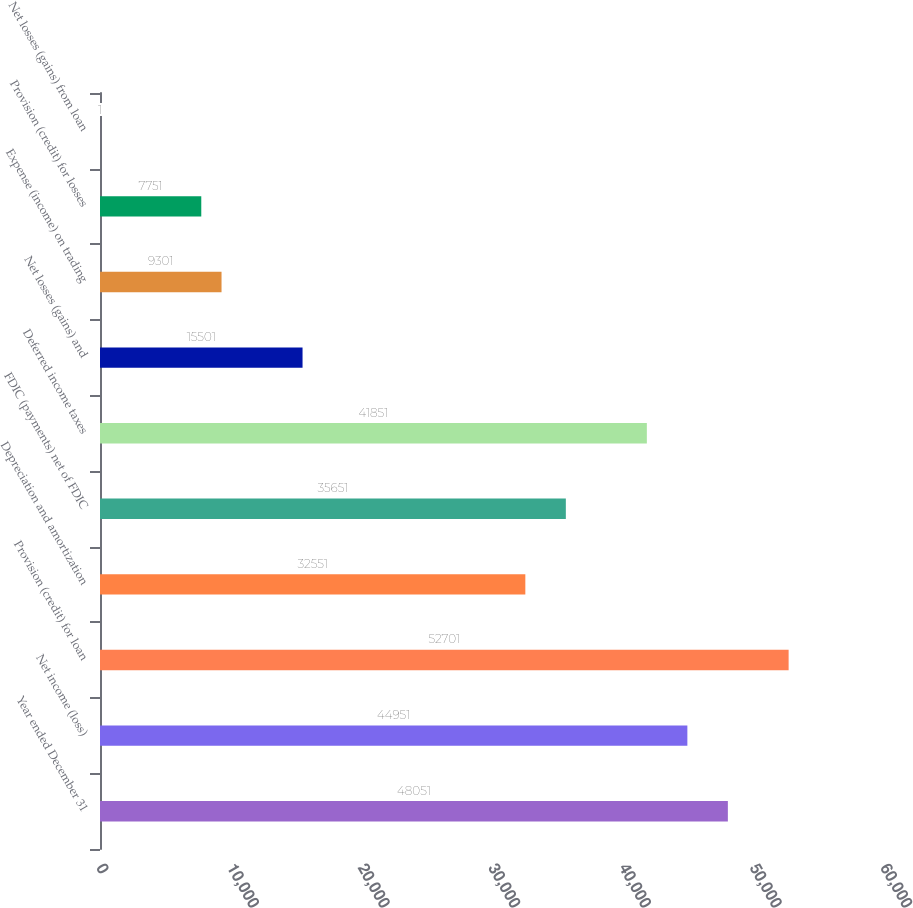Convert chart to OTSL. <chart><loc_0><loc_0><loc_500><loc_500><bar_chart><fcel>Year ended December 31<fcel>Net income (loss)<fcel>Provision (credit) for loan<fcel>Depreciation and amortization<fcel>FDIC (payments) net of FDIC<fcel>Deferred income taxes<fcel>Net losses (gains) and<fcel>Expense (income) on trading<fcel>Provision (credit) for losses<fcel>Net losses (gains) from loan<nl><fcel>48051<fcel>44951<fcel>52701<fcel>32551<fcel>35651<fcel>41851<fcel>15501<fcel>9301<fcel>7751<fcel>1<nl></chart> 